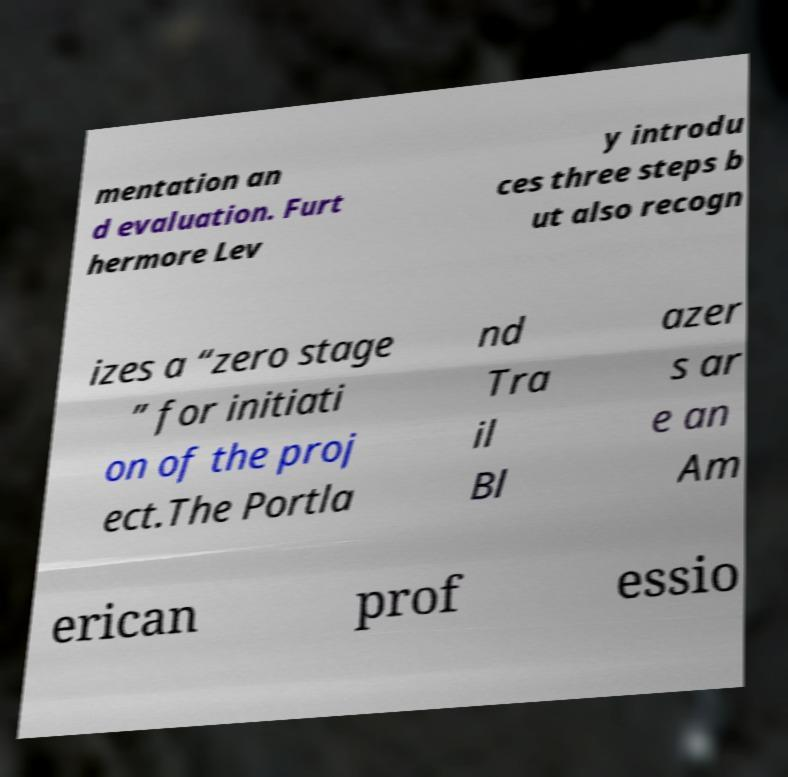Could you assist in decoding the text presented in this image and type it out clearly? mentation an d evaluation. Furt hermore Lev y introdu ces three steps b ut also recogn izes a “zero stage ” for initiati on of the proj ect.The Portla nd Tra il Bl azer s ar e an Am erican prof essio 